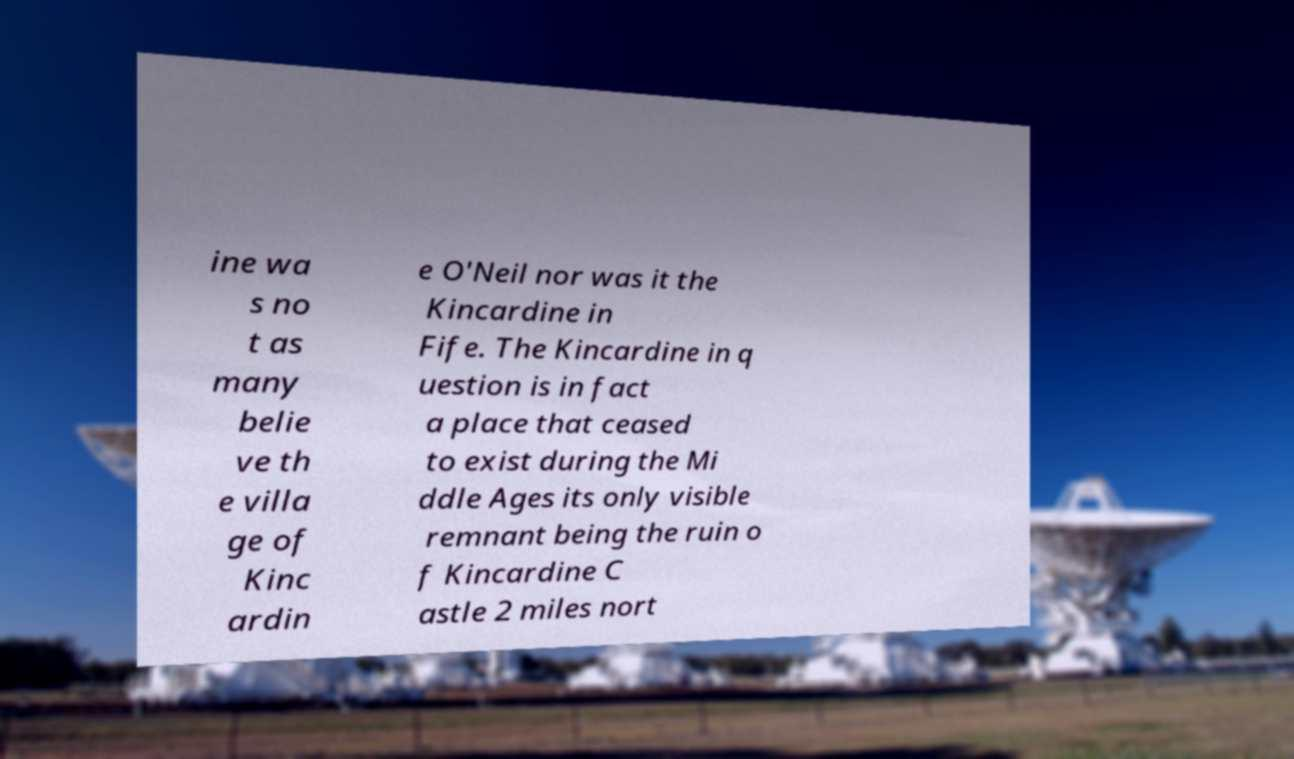Could you extract and type out the text from this image? ine wa s no t as many belie ve th e villa ge of Kinc ardin e O'Neil nor was it the Kincardine in Fife. The Kincardine in q uestion is in fact a place that ceased to exist during the Mi ddle Ages its only visible remnant being the ruin o f Kincardine C astle 2 miles nort 